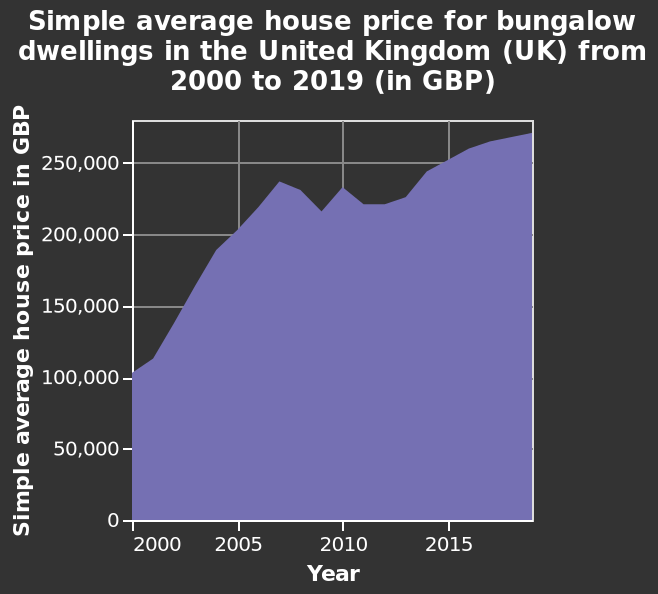<image>
What is the name of the area graph?  The area graph is named "Simple average house price for bungalow dwellings in the United Kingdom (UK) from 2000 to 2019 (in GBP)." Describe the following image in detail Here a is a area graph named Simple average house price for bungalow dwellings in the United Kingdom (UK) from 2000 to 2019 (in GBP). The x-axis measures Year on linear scale of range 2000 to 2015 while the y-axis measures Simple average house price in GBP on linear scale from 0 to 250,000. Offer a thorough analysis of the image. House prices peaked between 2005 and 2010 they then had a sharp decrease. Over the last 10 years house prices have been gradually increasing with no sudden decline. When did the average house price start to grow again after the small decrease in 2008?  The average house price started to grow again after 2008. What happened to the average house price between 2000 and 2005?  The average house price doubled between 2000 and 2005. 